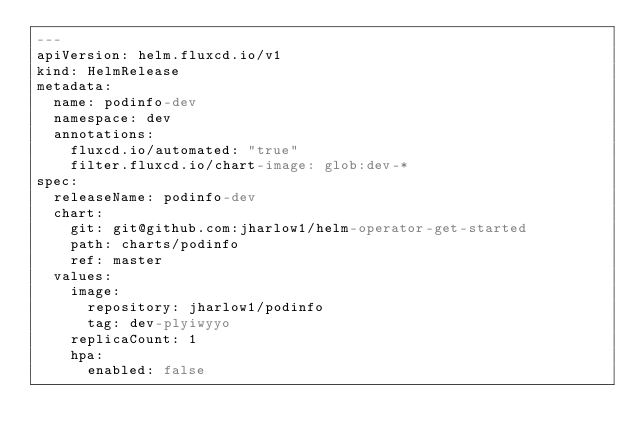Convert code to text. <code><loc_0><loc_0><loc_500><loc_500><_YAML_>---
apiVersion: helm.fluxcd.io/v1
kind: HelmRelease
metadata:
  name: podinfo-dev
  namespace: dev
  annotations:
    fluxcd.io/automated: "true"
    filter.fluxcd.io/chart-image: glob:dev-*
spec:
  releaseName: podinfo-dev
  chart:
    git: git@github.com:jharlow1/helm-operator-get-started
    path: charts/podinfo
    ref: master
  values:
    image:
      repository: jharlow1/podinfo
      tag: dev-plyiwyyo
    replicaCount: 1
    hpa:
      enabled: false
</code> 